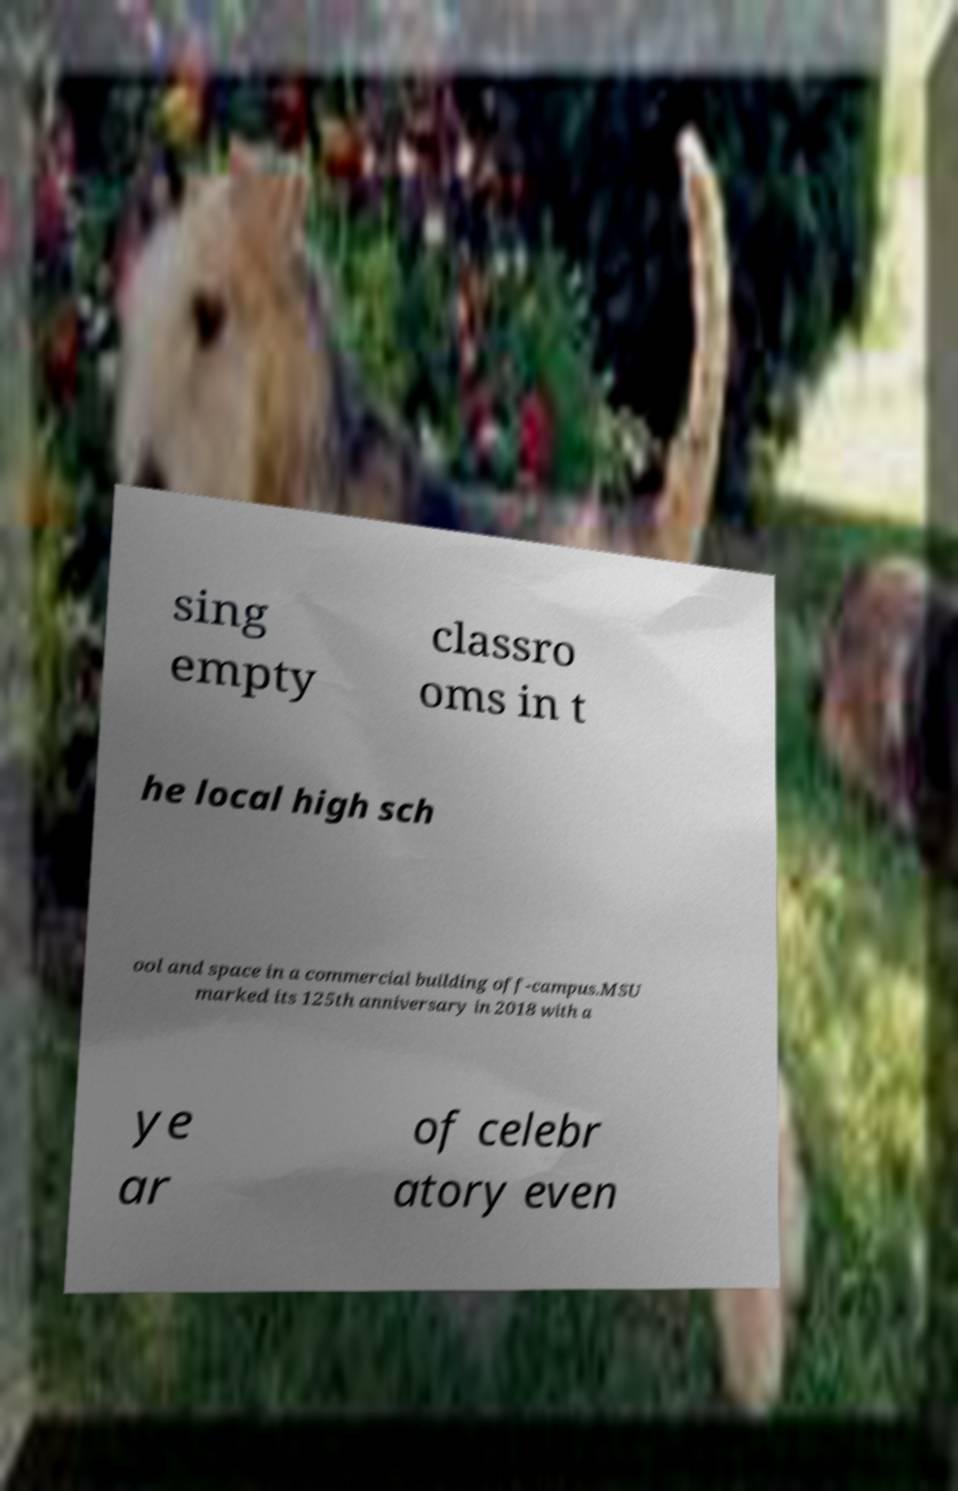I need the written content from this picture converted into text. Can you do that? sing empty classro oms in t he local high sch ool and space in a commercial building off-campus.MSU marked its 125th anniversary in 2018 with a ye ar of celebr atory even 